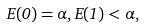<formula> <loc_0><loc_0><loc_500><loc_500>E ( 0 ) = \alpha , E ( 1 ) < \alpha ,</formula> 